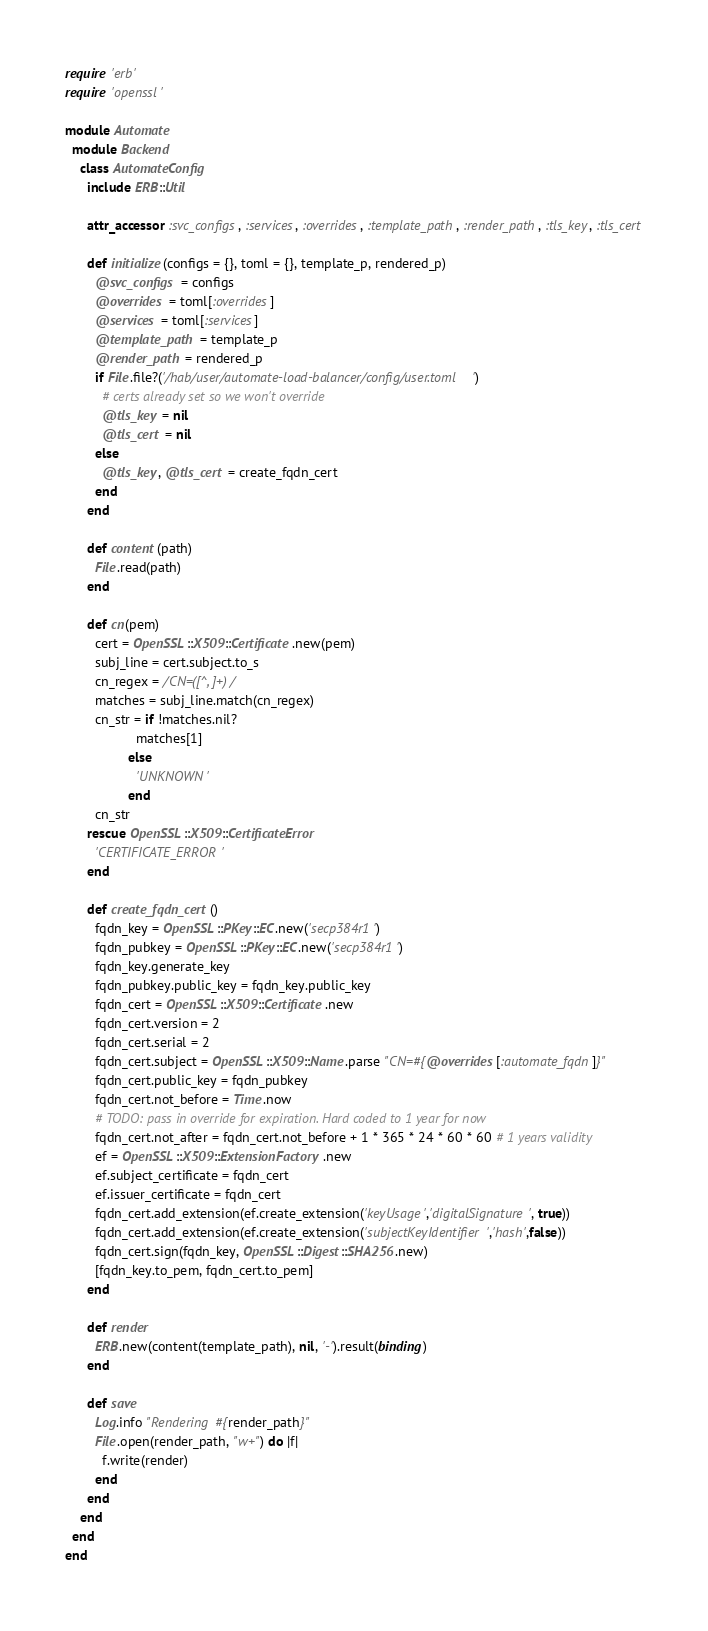Convert code to text. <code><loc_0><loc_0><loc_500><loc_500><_Ruby_>require 'erb'
require 'openssl'

module Automate
  module Backend
    class AutomateConfig
      include ERB::Util

      attr_accessor :svc_configs, :services, :overrides, :template_path, :render_path, :tls_key, :tls_cert

      def initialize(configs = {}, toml = {}, template_p, rendered_p)
        @svc_configs = configs
        @overrides = toml[:overrides]
        @services = toml[:services]
        @template_path = template_p
        @render_path = rendered_p
        if File.file?('/hab/user/automate-load-balancer/config/user.toml')
          # certs already set so we won't override
          @tls_key = nil
          @tls_cert = nil
        else
          @tls_key, @tls_cert = create_fqdn_cert
        end
      end

      def content(path)
        File.read(path)
      end

      def cn(pem)
        cert = OpenSSL::X509::Certificate.new(pem)
        subj_line = cert.subject.to_s
        cn_regex = /CN=([^, ]+)/
        matches = subj_line.match(cn_regex)
        cn_str = if !matches.nil?
                   matches[1]
                 else
                   'UNKNOWN'
                 end
        cn_str
      rescue OpenSSL::X509::CertificateError
        'CERTIFICATE_ERROR'
      end

      def create_fqdn_cert()
        fqdn_key = OpenSSL::PKey::EC.new('secp384r1')
        fqdn_pubkey = OpenSSL::PKey::EC.new('secp384r1')
        fqdn_key.generate_key
        fqdn_pubkey.public_key = fqdn_key.public_key
        fqdn_cert = OpenSSL::X509::Certificate.new
        fqdn_cert.version = 2
        fqdn_cert.serial = 2
        fqdn_cert.subject = OpenSSL::X509::Name.parse "CN=#{@overrides[:automate_fqdn]}"
        fqdn_cert.public_key = fqdn_pubkey
        fqdn_cert.not_before = Time.now
        # TODO: pass in override for expiration. Hard coded to 1 year for now
        fqdn_cert.not_after = fqdn_cert.not_before + 1 * 365 * 24 * 60 * 60 # 1 years validity
        ef = OpenSSL::X509::ExtensionFactory.new
        ef.subject_certificate = fqdn_cert
        ef.issuer_certificate = fqdn_cert
        fqdn_cert.add_extension(ef.create_extension('keyUsage','digitalSignature', true))
        fqdn_cert.add_extension(ef.create_extension('subjectKeyIdentifier','hash',false))
        fqdn_cert.sign(fqdn_key, OpenSSL::Digest::SHA256.new)
        [fqdn_key.to_pem, fqdn_cert.to_pem]
      end

      def render
        ERB.new(content(template_path), nil, '-').result(binding)
      end

      def save
        Log.info "Rendering #{render_path}"
        File.open(render_path, "w+") do |f|
          f.write(render)
        end
      end
    end
  end
end
</code> 